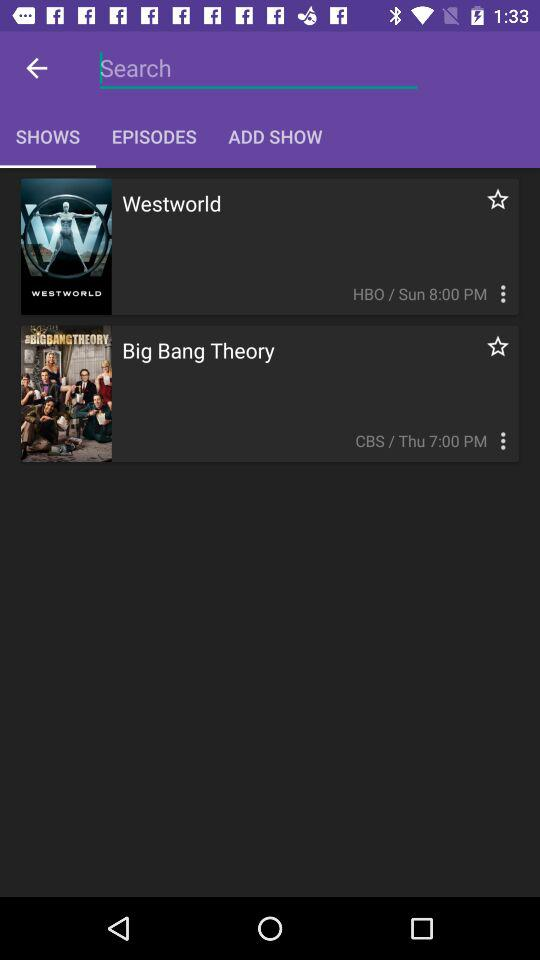On which channel the "Big Bang Theory" is telecasted? The "Big Bang Theory" is telecasted on the channel "CBS". 